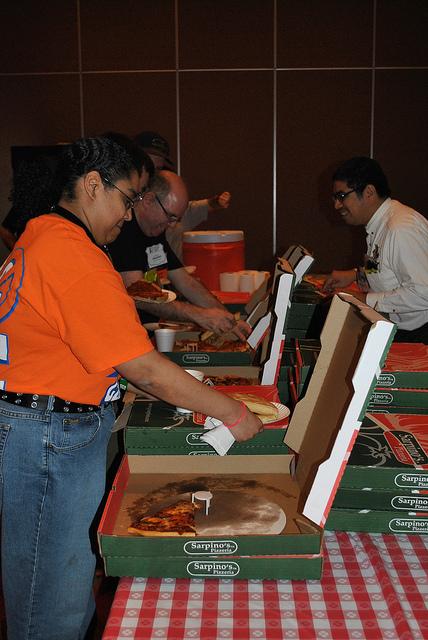What ate the men cutting into?
Be succinct. Pizza. Does the first person have on a belt?
Short answer required. Yes. What can you do with that design on the table?
Give a very brief answer. Play checkers. What is the little white thing in the center of the pizza box for?
Keep it brief. Protect pizza. What kind of food are the people eating?
Be succinct. Pizza. 